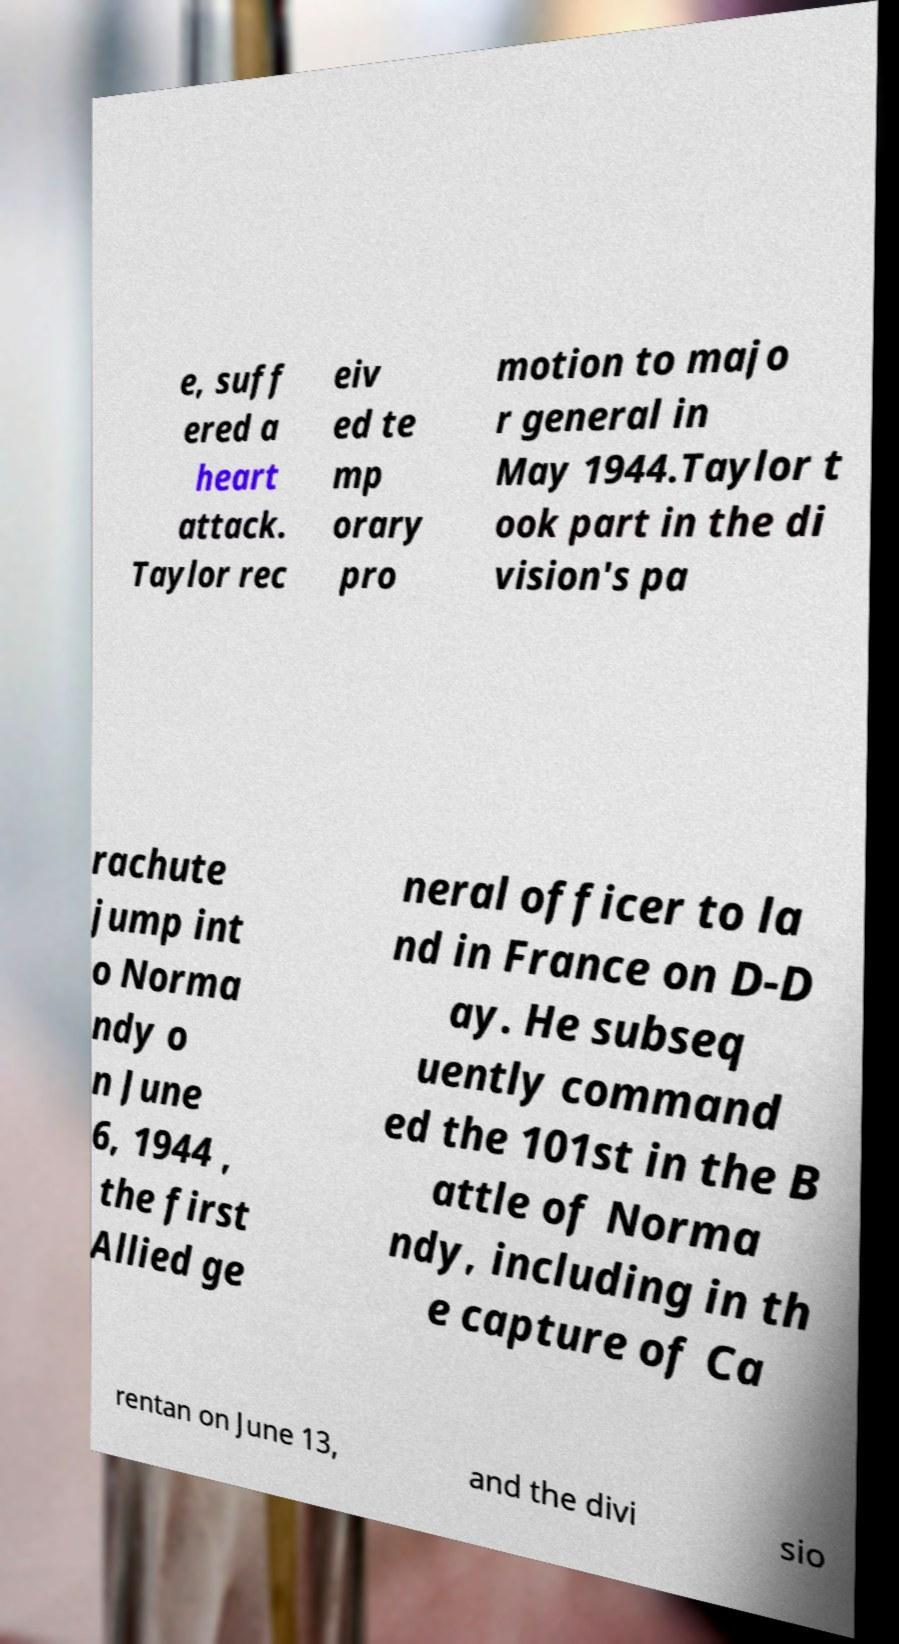Could you assist in decoding the text presented in this image and type it out clearly? e, suff ered a heart attack. Taylor rec eiv ed te mp orary pro motion to majo r general in May 1944.Taylor t ook part in the di vision's pa rachute jump int o Norma ndy o n June 6, 1944 , the first Allied ge neral officer to la nd in France on D-D ay. He subseq uently command ed the 101st in the B attle of Norma ndy, including in th e capture of Ca rentan on June 13, and the divi sio 